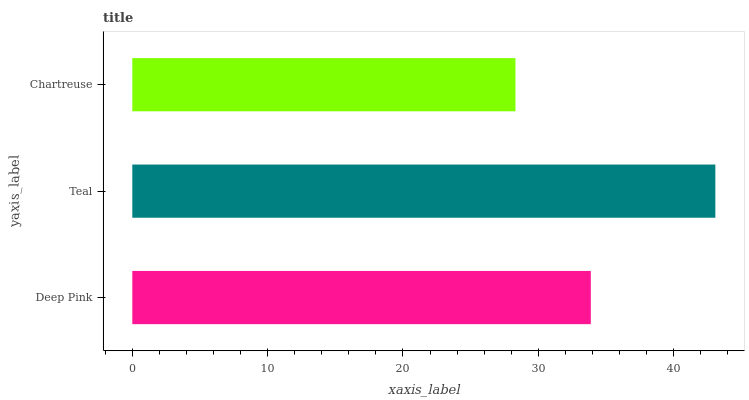Is Chartreuse the minimum?
Answer yes or no. Yes. Is Teal the maximum?
Answer yes or no. Yes. Is Teal the minimum?
Answer yes or no. No. Is Chartreuse the maximum?
Answer yes or no. No. Is Teal greater than Chartreuse?
Answer yes or no. Yes. Is Chartreuse less than Teal?
Answer yes or no. Yes. Is Chartreuse greater than Teal?
Answer yes or no. No. Is Teal less than Chartreuse?
Answer yes or no. No. Is Deep Pink the high median?
Answer yes or no. Yes. Is Deep Pink the low median?
Answer yes or no. Yes. Is Teal the high median?
Answer yes or no. No. Is Chartreuse the low median?
Answer yes or no. No. 